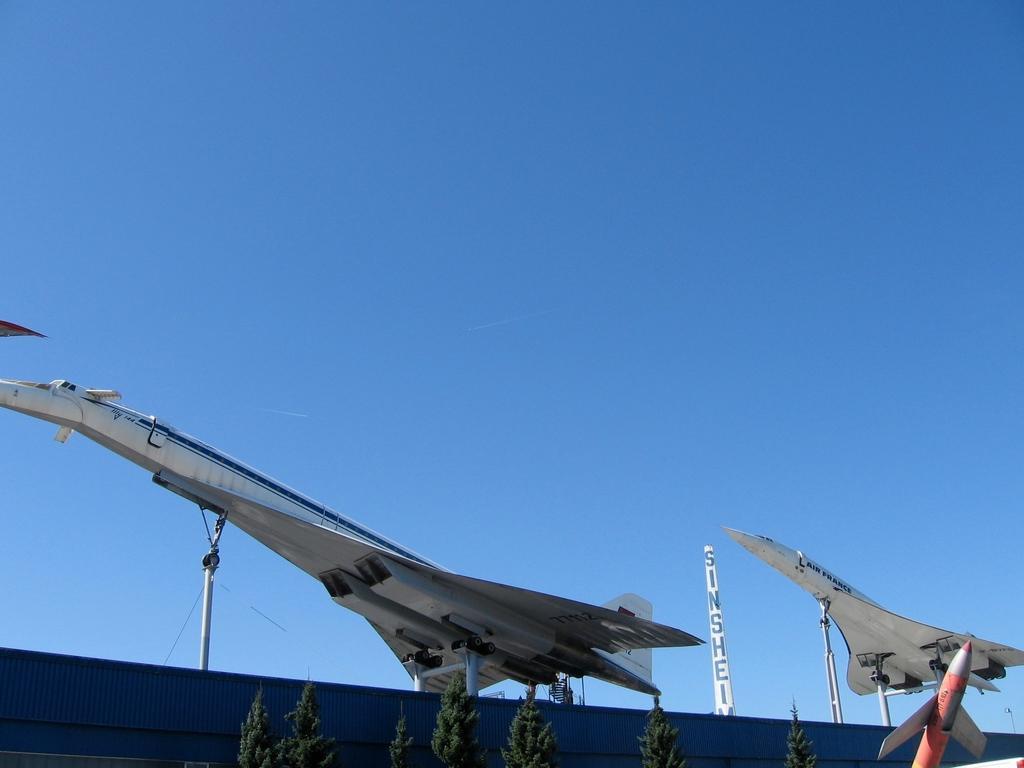Could you give a brief overview of what you see in this image? In this image, we can see some planes. We can also see an object with some text written on it. We can also see some trees. We can also see the sky. 